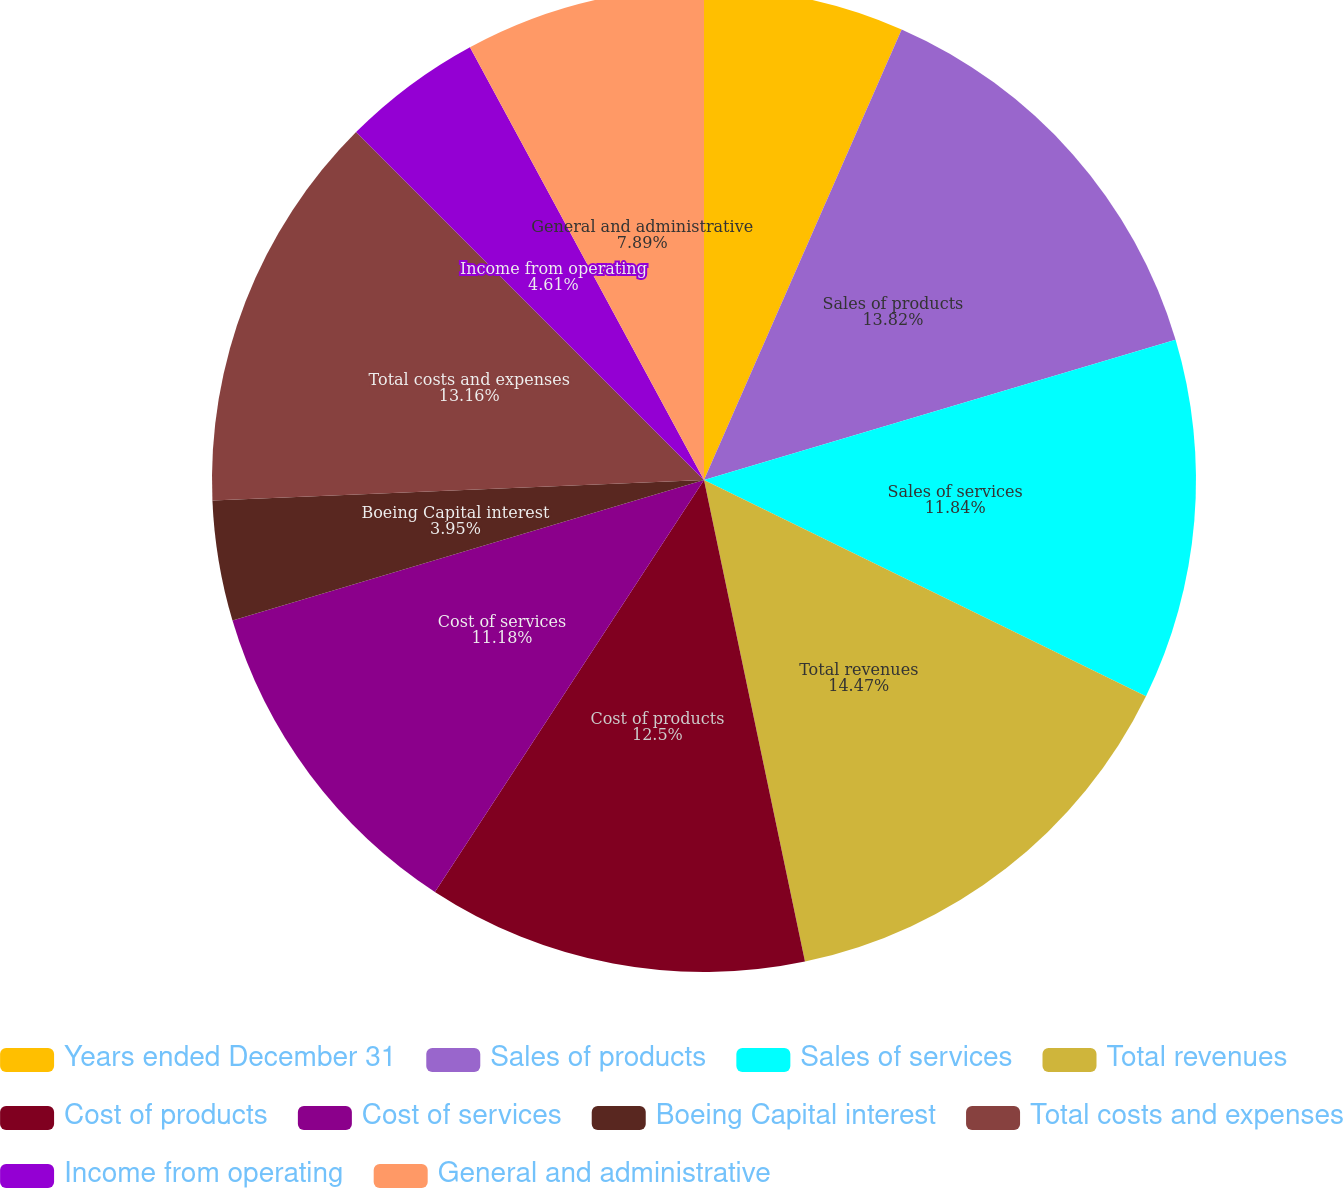Convert chart to OTSL. <chart><loc_0><loc_0><loc_500><loc_500><pie_chart><fcel>Years ended December 31<fcel>Sales of products<fcel>Sales of services<fcel>Total revenues<fcel>Cost of products<fcel>Cost of services<fcel>Boeing Capital interest<fcel>Total costs and expenses<fcel>Income from operating<fcel>General and administrative<nl><fcel>6.58%<fcel>13.82%<fcel>11.84%<fcel>14.47%<fcel>12.5%<fcel>11.18%<fcel>3.95%<fcel>13.16%<fcel>4.61%<fcel>7.89%<nl></chart> 